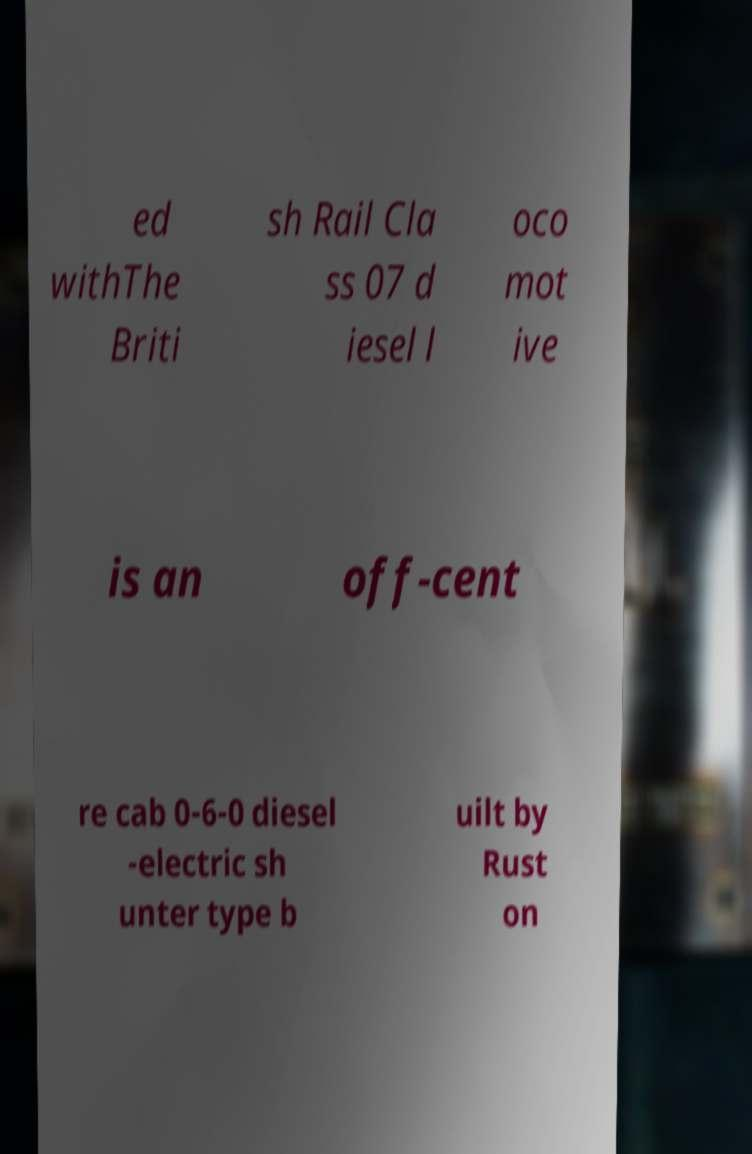Can you read and provide the text displayed in the image?This photo seems to have some interesting text. Can you extract and type it out for me? ed withThe Briti sh Rail Cla ss 07 d iesel l oco mot ive is an off-cent re cab 0-6-0 diesel -electric sh unter type b uilt by Rust on 